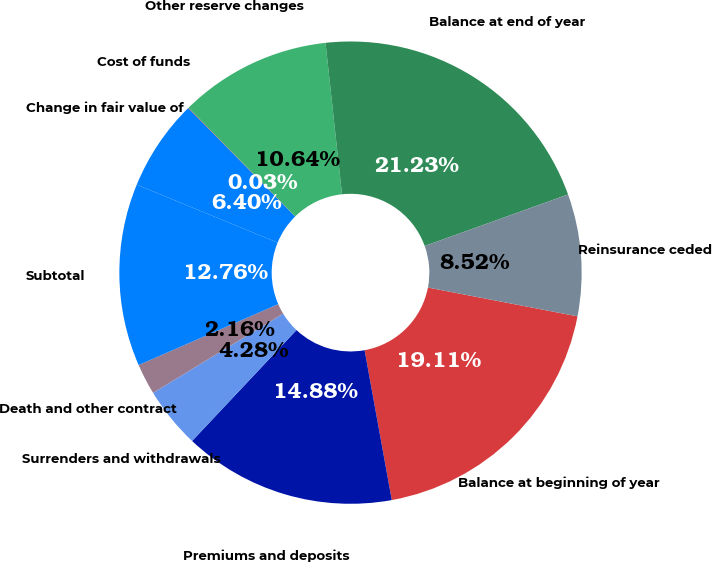<chart> <loc_0><loc_0><loc_500><loc_500><pie_chart><fcel>Balance at beginning of year<fcel>Premiums and deposits<fcel>Surrenders and withdrawals<fcel>Death and other contract<fcel>Subtotal<fcel>Change in fair value of<fcel>Cost of funds<fcel>Other reserve changes<fcel>Balance at end of year<fcel>Reinsurance ceded<nl><fcel>19.12%<fcel>14.88%<fcel>4.28%<fcel>2.16%<fcel>12.76%<fcel>6.4%<fcel>0.03%<fcel>10.64%<fcel>21.24%<fcel>8.52%<nl></chart> 